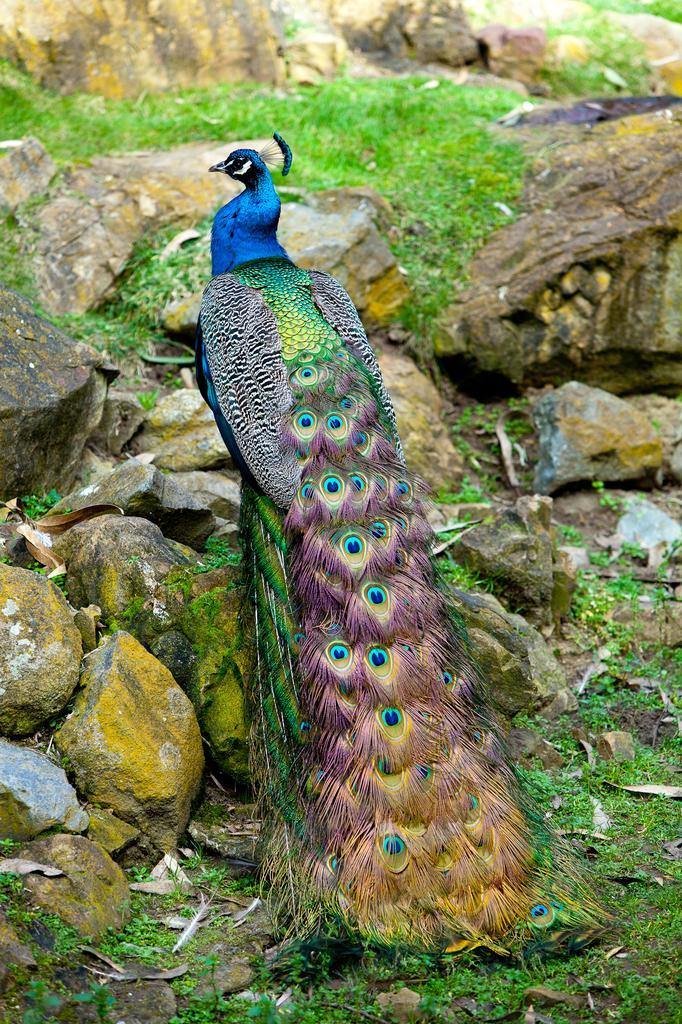In one or two sentences, can you explain what this image depicts? In the center of the image we can see a peacock. We can also see some stones, the rock, grass and some quills on the ground. 